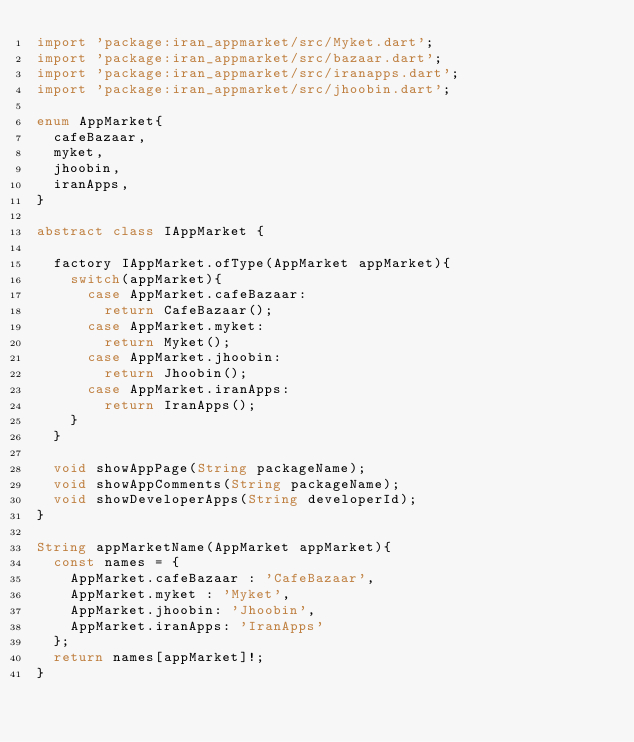Convert code to text. <code><loc_0><loc_0><loc_500><loc_500><_Dart_>import 'package:iran_appmarket/src/Myket.dart';
import 'package:iran_appmarket/src/bazaar.dart';
import 'package:iran_appmarket/src/iranapps.dart';
import 'package:iran_appmarket/src/jhoobin.dart';

enum AppMarket{
  cafeBazaar,
  myket,
  jhoobin,
  iranApps,
}

abstract class IAppMarket {

  factory IAppMarket.ofType(AppMarket appMarket){
    switch(appMarket){
      case AppMarket.cafeBazaar:
        return CafeBazaar();
      case AppMarket.myket:
        return Myket();
      case AppMarket.jhoobin:
        return Jhoobin();
      case AppMarket.iranApps:
        return IranApps();
    }
  }

  void showAppPage(String packageName);
  void showAppComments(String packageName);
  void showDeveloperApps(String developerId);
}

String appMarketName(AppMarket appMarket){
  const names = {
    AppMarket.cafeBazaar : 'CafeBazaar',
    AppMarket.myket : 'Myket',
    AppMarket.jhoobin: 'Jhoobin',
    AppMarket.iranApps: 'IranApps'
  };
  return names[appMarket]!;
}</code> 